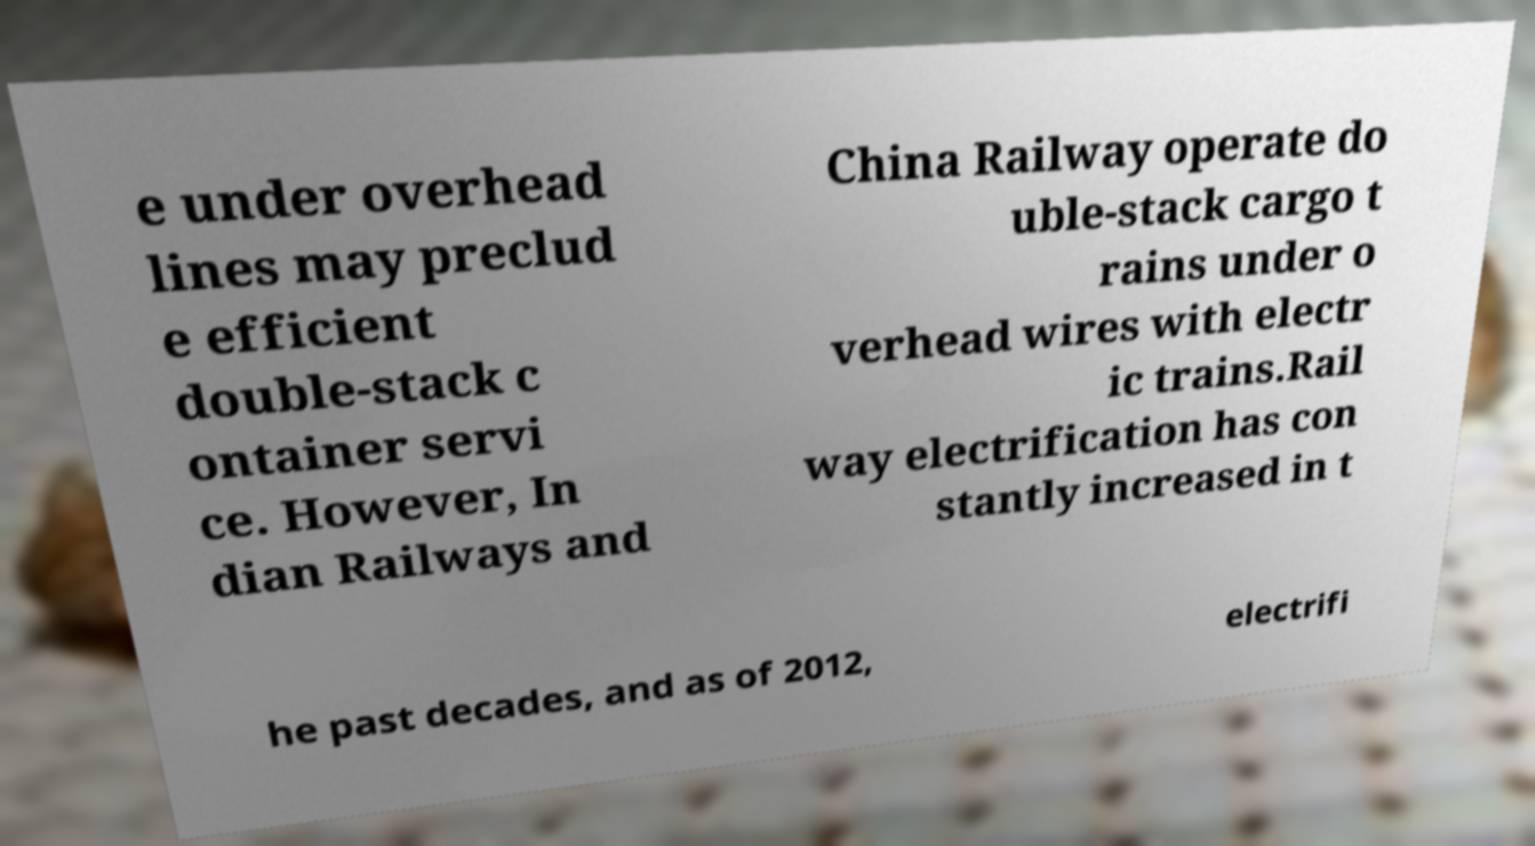Could you extract and type out the text from this image? e under overhead lines may preclud e efficient double-stack c ontainer servi ce. However, In dian Railways and China Railway operate do uble-stack cargo t rains under o verhead wires with electr ic trains.Rail way electrification has con stantly increased in t he past decades, and as of 2012, electrifi 